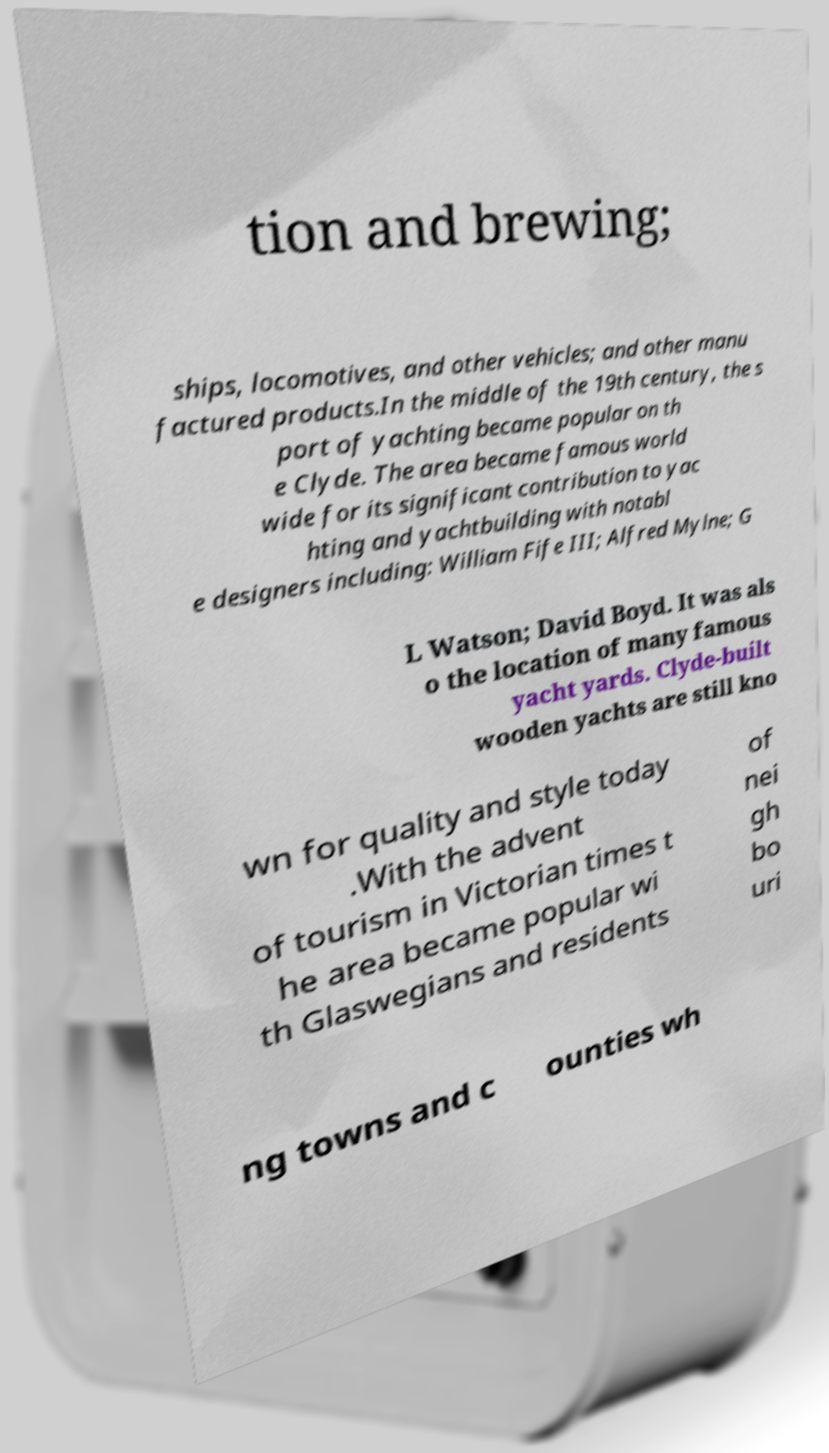Could you extract and type out the text from this image? tion and brewing; ships, locomotives, and other vehicles; and other manu factured products.In the middle of the 19th century, the s port of yachting became popular on th e Clyde. The area became famous world wide for its significant contribution to yac hting and yachtbuilding with notabl e designers including: William Fife III; Alfred Mylne; G L Watson; David Boyd. It was als o the location of many famous yacht yards. Clyde-built wooden yachts are still kno wn for quality and style today .With the advent of tourism in Victorian times t he area became popular wi th Glaswegians and residents of nei gh bo uri ng towns and c ounties wh 